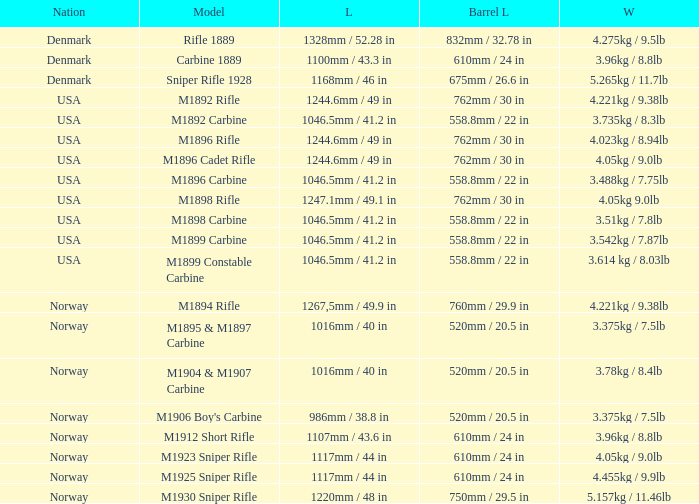What is Length, when Barrel Length is 750mm / 29.5 in? 1220mm / 48 in. 